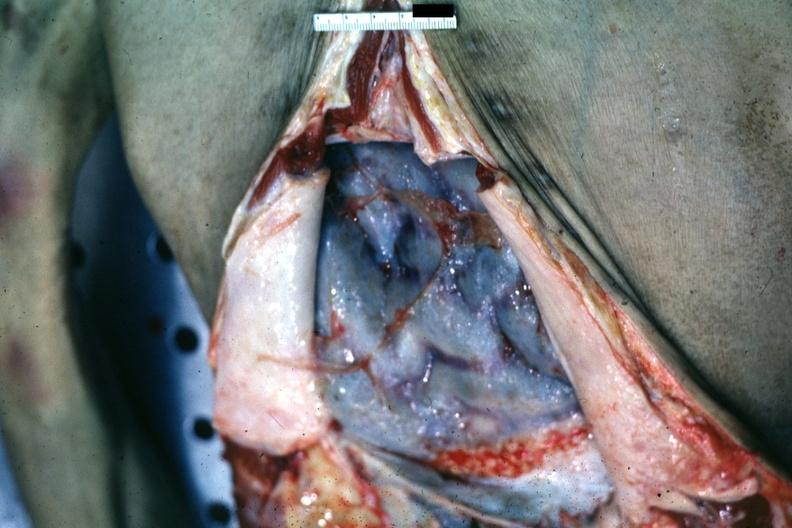s peritoneum present?
Answer the question using a single word or phrase. Yes 